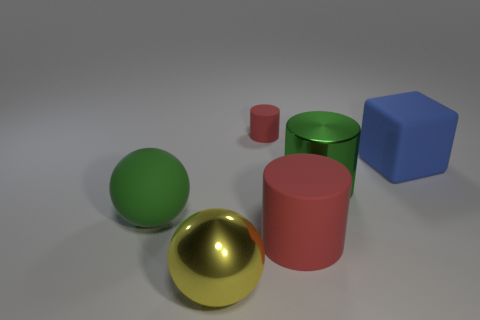Add 2 small red cylinders. How many objects exist? 8 Subtract all blocks. How many objects are left? 5 Add 4 brown shiny balls. How many brown shiny balls exist? 4 Subtract 0 brown balls. How many objects are left? 6 Subtract all small cyan blocks. Subtract all green rubber spheres. How many objects are left? 5 Add 3 red rubber objects. How many red rubber objects are left? 5 